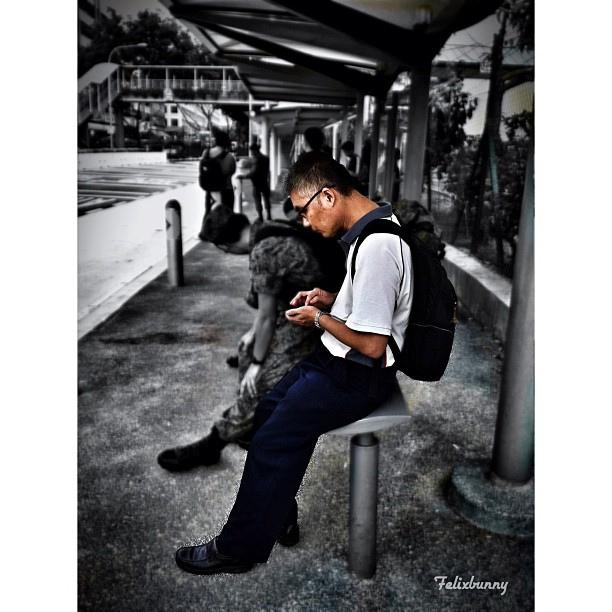Where is the man storing his things?

Choices:
A) suitcase
B) duffel bag
C) purse
D) backpack backpack 